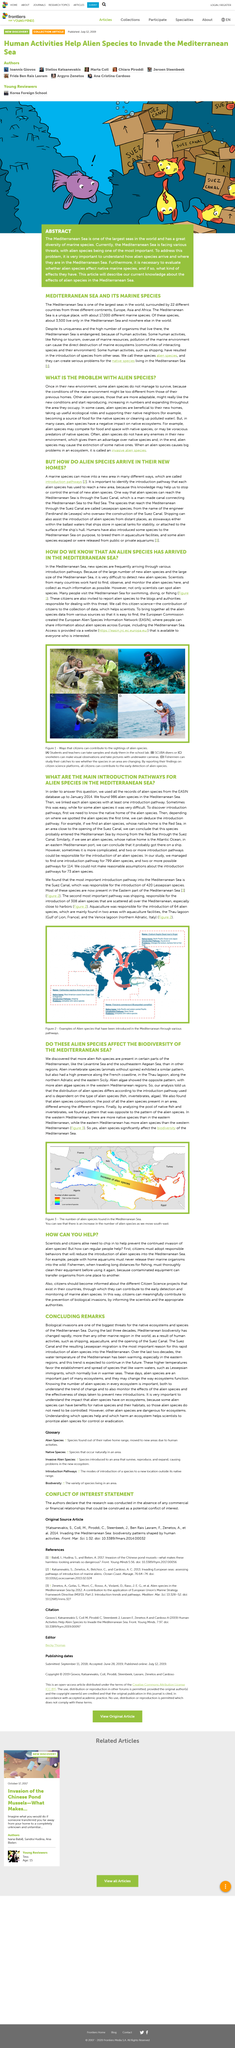Identify some key points in this picture. The Western Mediterranean is home to a diverse range of native species, including many types of fish and marine life. The Red Sea is the other body of water that can be easily accessed through the Suez Canal. The Eastern Mediterranean is home to a diverse range of alien species. The Suez Canal is the primary entry point into the Mediterranean Sea. It is challenging to accurately identify the number of new alien species in the sea, particularly in the Mediterranean Sea, due to the vast size of the sea and the large number of existing alien species. 